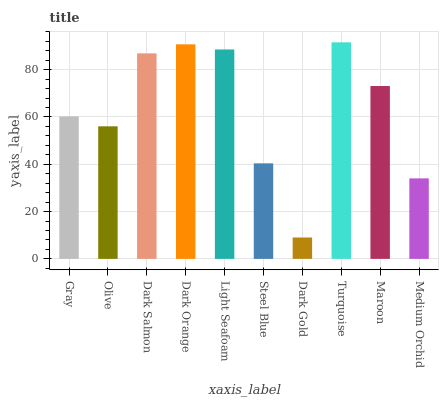Is Dark Gold the minimum?
Answer yes or no. Yes. Is Turquoise the maximum?
Answer yes or no. Yes. Is Olive the minimum?
Answer yes or no. No. Is Olive the maximum?
Answer yes or no. No. Is Gray greater than Olive?
Answer yes or no. Yes. Is Olive less than Gray?
Answer yes or no. Yes. Is Olive greater than Gray?
Answer yes or no. No. Is Gray less than Olive?
Answer yes or no. No. Is Maroon the high median?
Answer yes or no. Yes. Is Gray the low median?
Answer yes or no. Yes. Is Light Seafoam the high median?
Answer yes or no. No. Is Medium Orchid the low median?
Answer yes or no. No. 